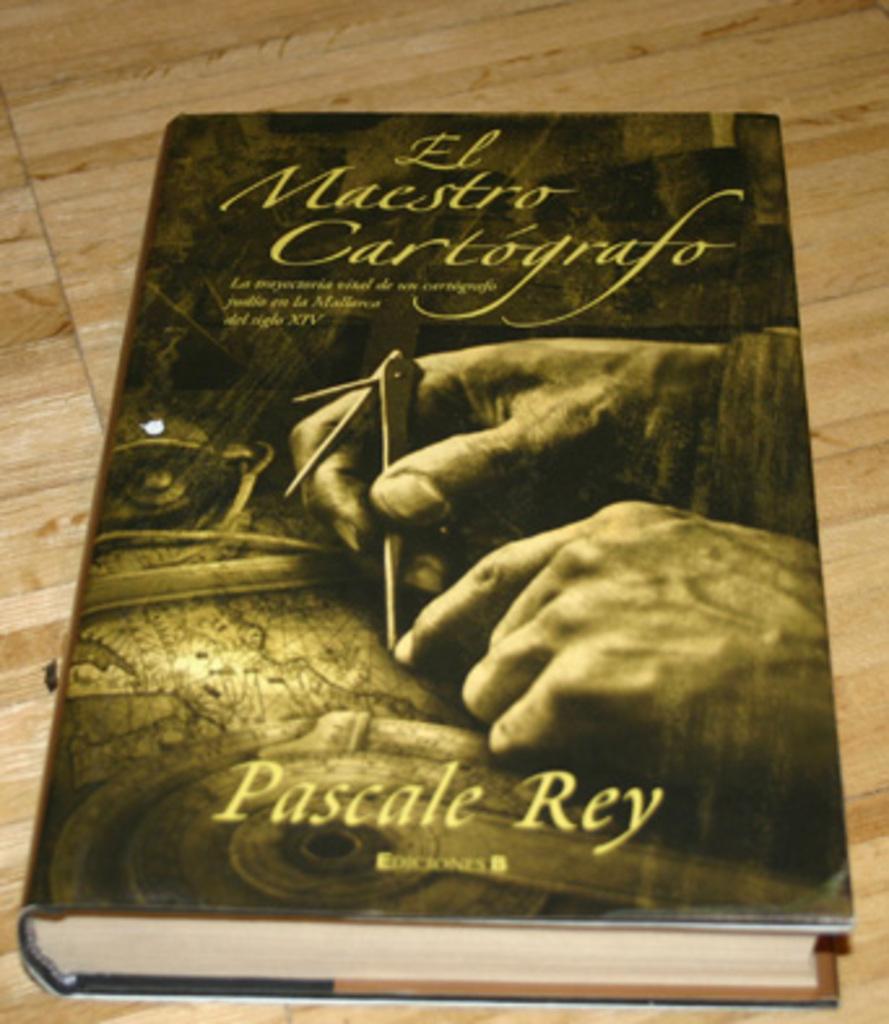What is the name of this novel?
Provide a short and direct response. El maestro cartografo. 